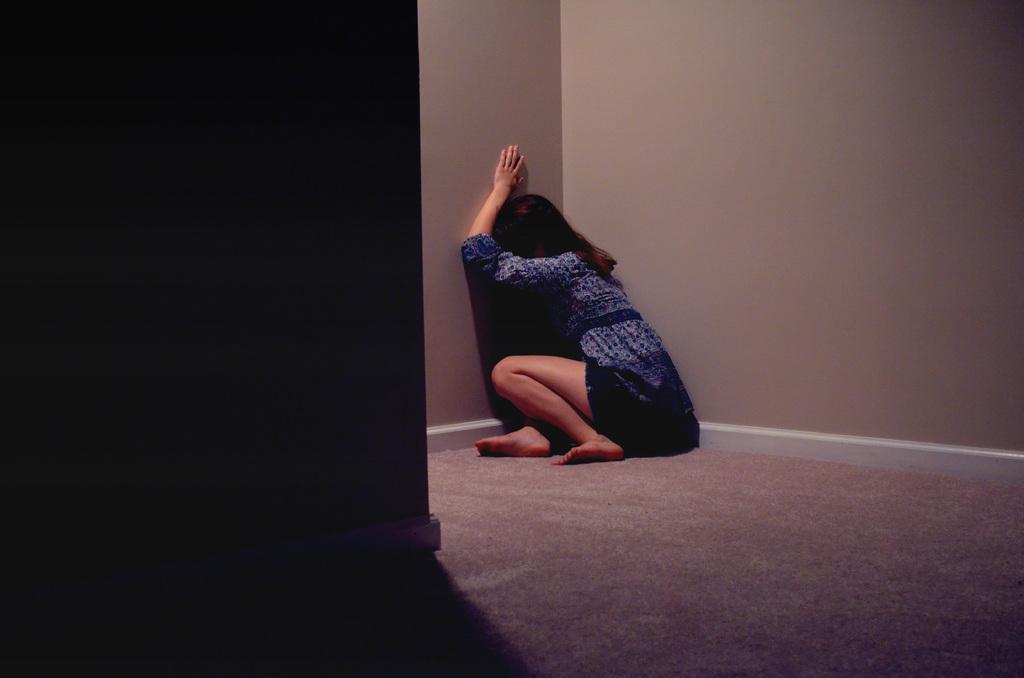Describe this image in one or two sentences. In this picture I can see a girl sitting on the carpet, and in the background there is a wall. 